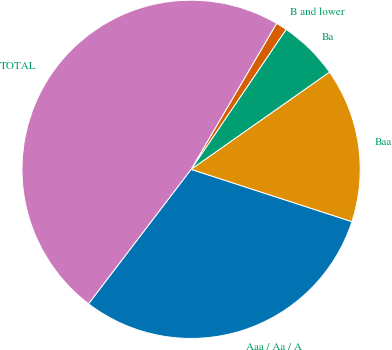<chart> <loc_0><loc_0><loc_500><loc_500><pie_chart><fcel>Aaa / Aa / A<fcel>Baa<fcel>Ba<fcel>B and lower<fcel>TOTAL<nl><fcel>30.37%<fcel>14.75%<fcel>5.76%<fcel>1.06%<fcel>48.06%<nl></chart> 